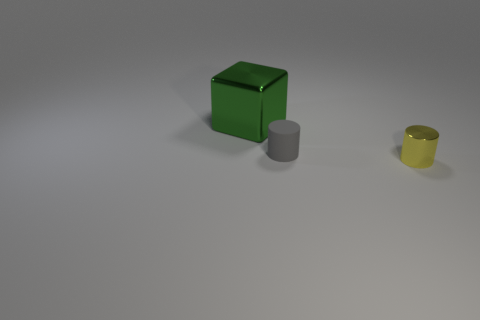What is the shape of the object that is in front of the large green block and to the left of the tiny yellow thing?
Ensure brevity in your answer.  Cylinder. How many objects are either cylinders or metal things that are on the left side of the gray cylinder?
Make the answer very short. 3. There is a yellow object that is the same shape as the gray matte thing; what material is it?
Offer a very short reply. Metal. Is there anything else that is the same material as the gray cylinder?
Ensure brevity in your answer.  No. What number of other yellow objects are the same shape as the small rubber object?
Your response must be concise. 1. There is a shiny thing that is behind the metal thing in front of the green metal object; what is its color?
Your response must be concise. Green. Are there an equal number of metallic things that are behind the small matte object and tiny yellow cylinders?
Give a very brief answer. Yes. Are there any other cylinders of the same size as the metallic cylinder?
Your answer should be very brief. Yes. Do the shiny cylinder and the cylinder behind the small yellow cylinder have the same size?
Ensure brevity in your answer.  Yes. Are there an equal number of small metal things behind the large metallic cube and big green metallic cubes behind the rubber cylinder?
Offer a terse response. No. 